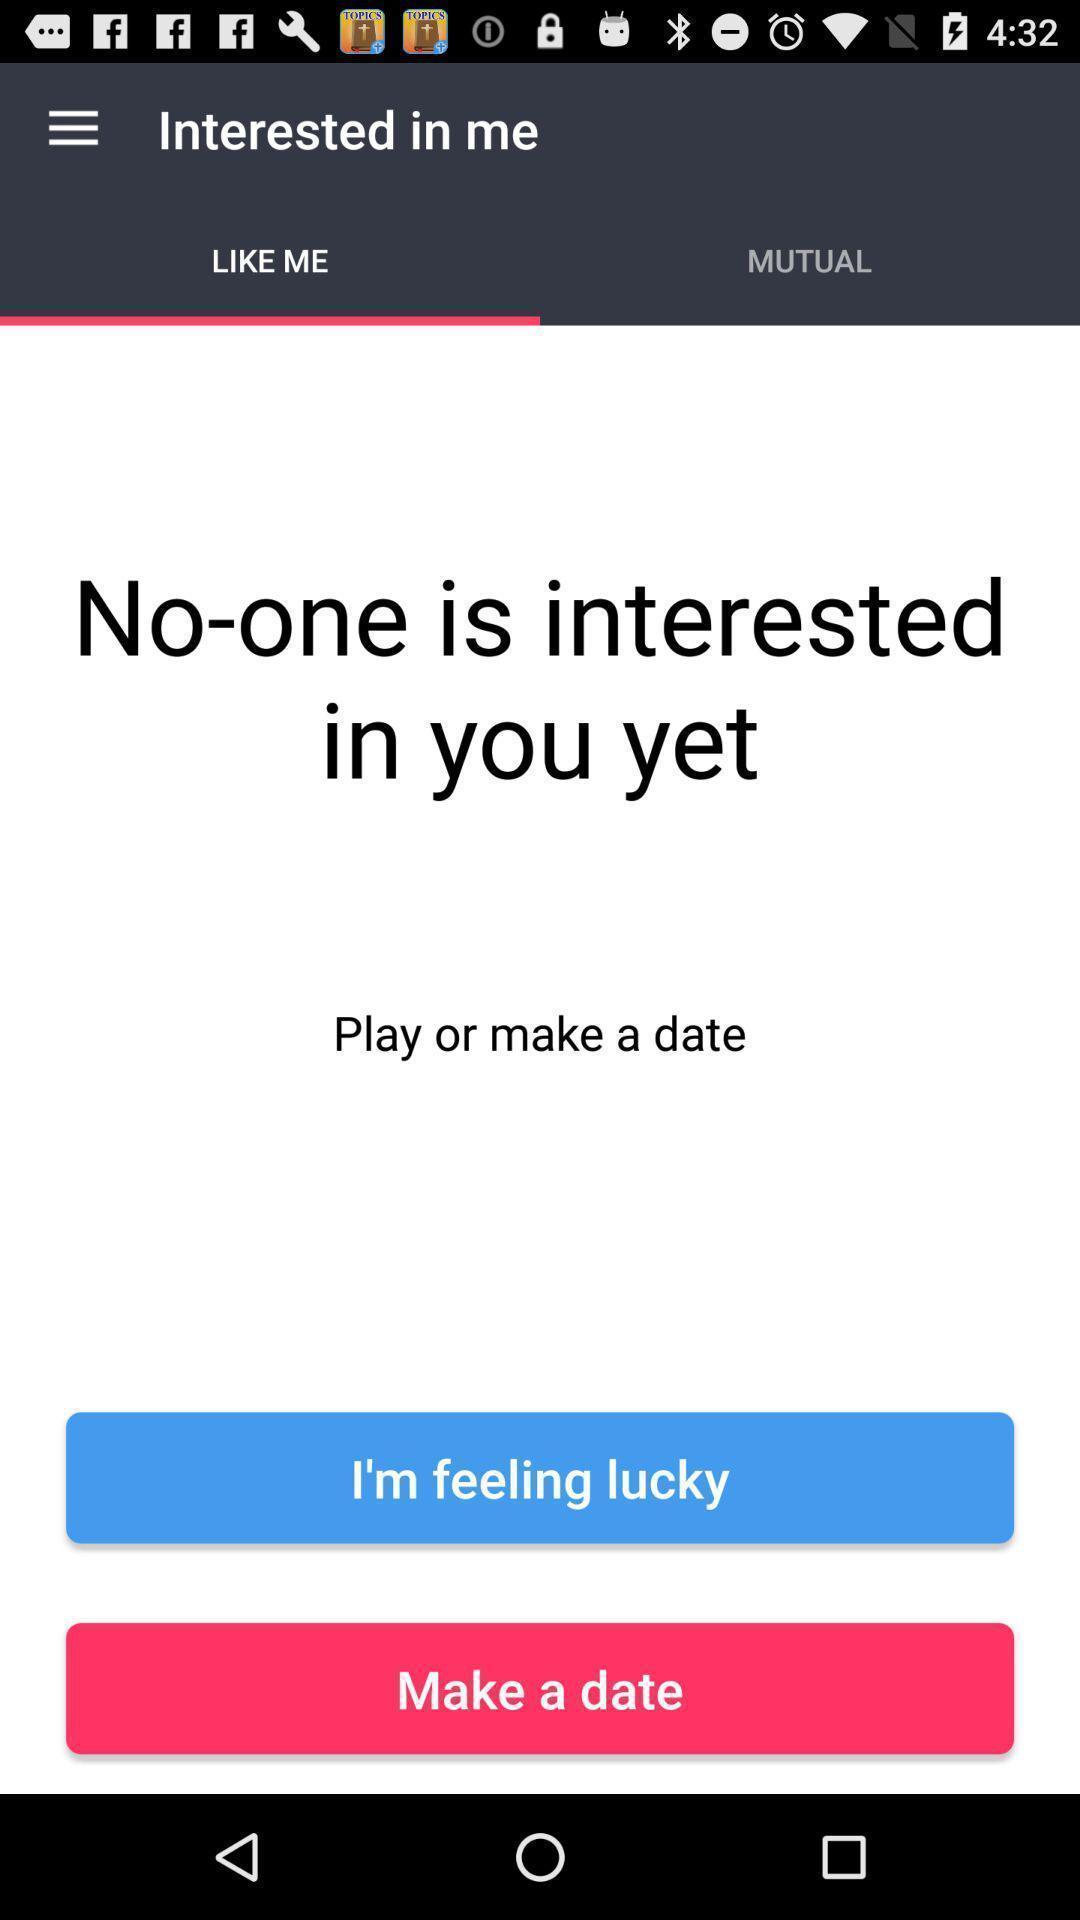Summarize the information in this screenshot. Screen shows about a dating app. 